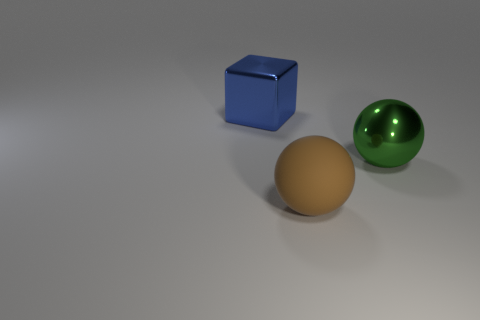If I were to use these objects in a physics experiment to study collisions, which aspects should I consider given their appearances? For a physics experiment involving collisions, you'd want to consider the materials the objects are made of, which is suggested by their appearance. The blue cube may be heavier and more solid, possibly affecting the outcome of a collision. Conversely, the green sphere looks metallic, which might mean it's hollow and reacts differently to impacts. You should also take into account the sizes and shapes, as these affect how objects interact upon collision. 